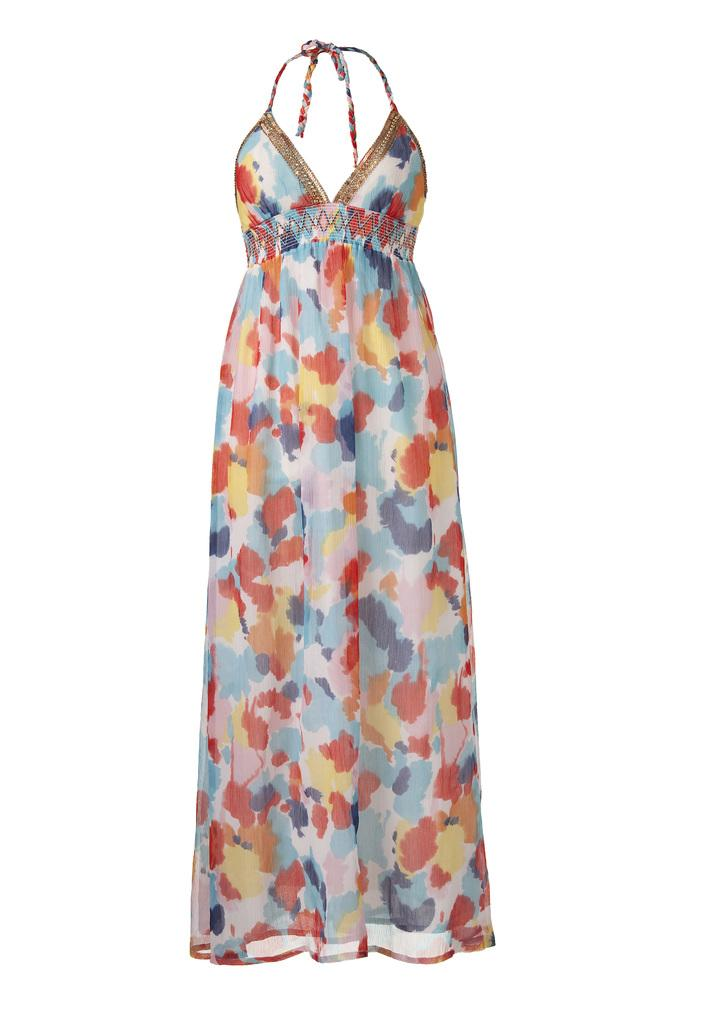What type of clothing is featured in the image? There is a dress in the image. What color is the background of the image? The background of the image is white. What flavor of bath soap is shown in the image? There is no bath soap present in the image; it features a dress and a white background. What type of cable is connected to the dress in the image? There is no cable connected to the dress in the image. 